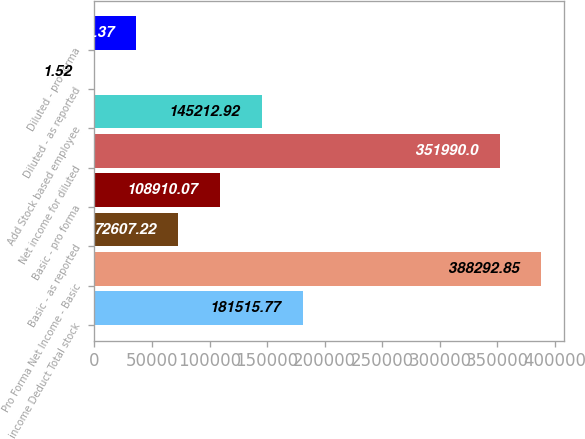<chart> <loc_0><loc_0><loc_500><loc_500><bar_chart><fcel>income Deduct Total stock<fcel>Pro Forma Net Income - Basic<fcel>Basic - as reported<fcel>Basic - pro forma<fcel>Net income for diluted<fcel>Add Stock based employee<fcel>Diluted - as reported<fcel>Diluted - pro forma<nl><fcel>181516<fcel>388293<fcel>72607.2<fcel>108910<fcel>351990<fcel>145213<fcel>1.52<fcel>36304.4<nl></chart> 